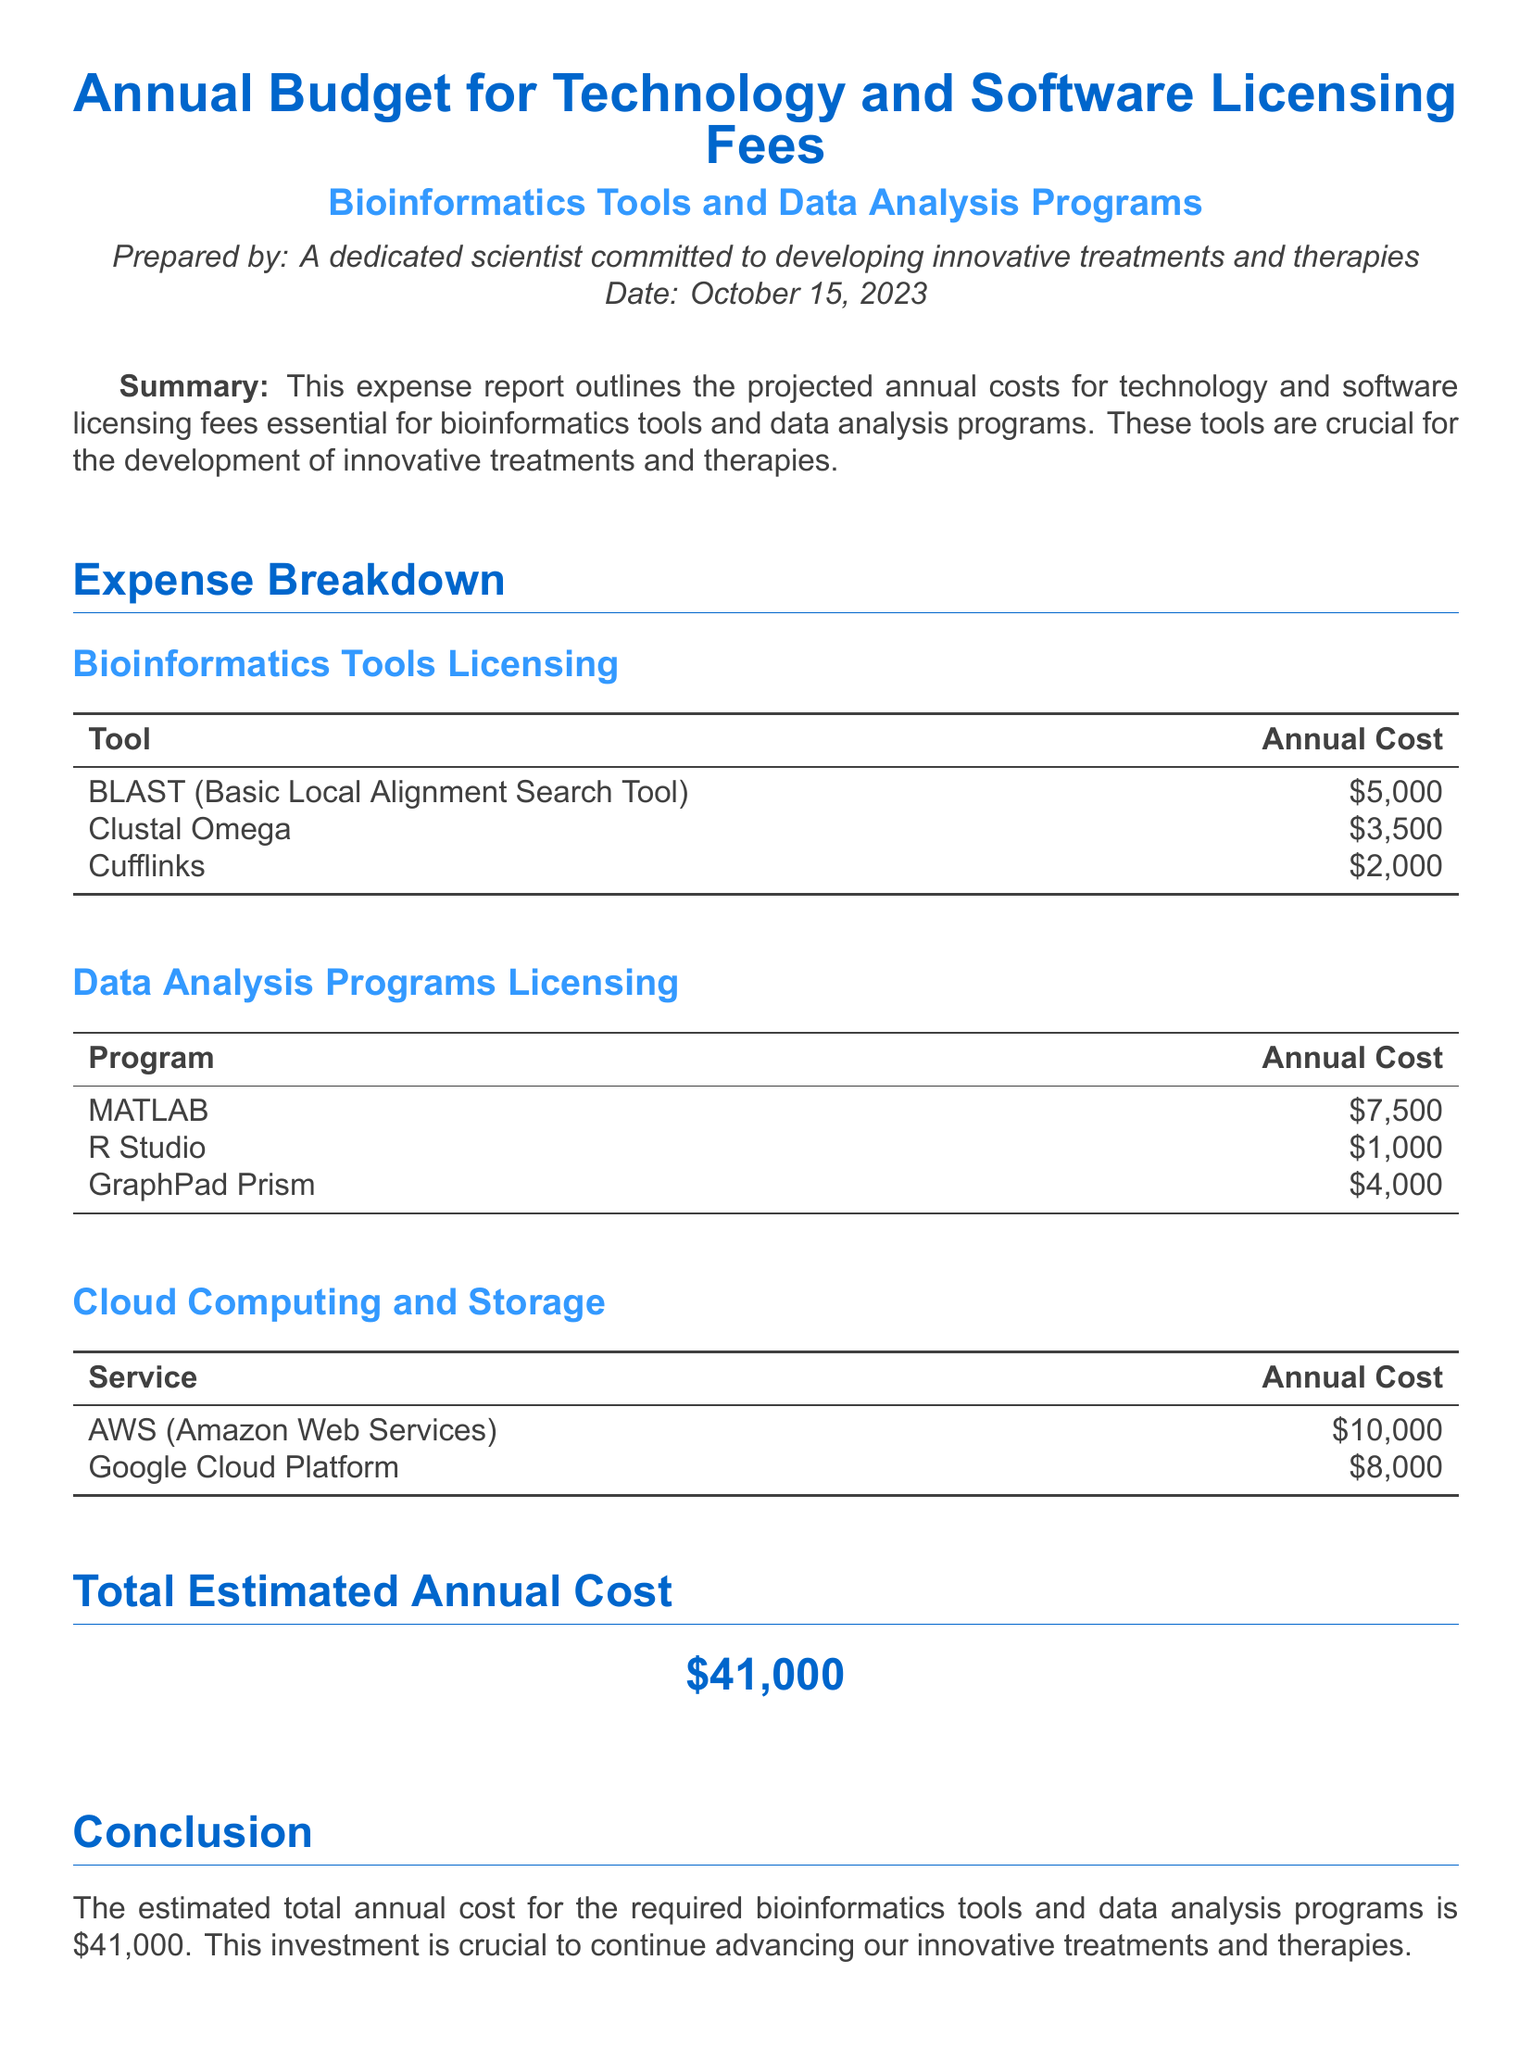what is the total estimated annual cost? The total estimated annual cost is presented in the document as the overall investment for the required tools and programs, which amounts to $41,000.
Answer: $41,000 how much does MATLAB cost annually? The document specifies the annual cost for MATLAB when listing data analysis programs licensing, which is $7,500.
Answer: $7,500 which service has the highest annual cost in cloud computing? The document provides a breakdown of cloud computing costs, identifying AWS as the service with the highest annual cost of $10,000.
Answer: AWS what are the total expenses for Bioinformatics Tools Licensing? To determine the total for Bioinformatics Tools Licensing, we sum the individual costs listed, which are $5,000, $3,500, and $2,000, totaling $10,500.
Answer: $10,500 who prepared the report? The report states that it was prepared by a dedicated scientist focused on innovative treatments and therapies, thus identifying the preparer.
Answer: A dedicated scientist what is the purpose of this document? The document outlines the projected annual costs for licensing fees that are essential for bioinformatics tools and data analysis programs, indicating its primary aim.
Answer: Expense report how many data analysis programs are listed in the report? The document lists three data analysis programs under licensing costs, which provides a specific count.
Answer: 3 what color is used for headings in the document? The document describes that headings are in a specific color indicated as heading color, which is RGB color (0, 102, 204).
Answer: RGB(0, 102, 204) which program is the least expensive in Data Analysis Programs Licensing? The document indicates that R Studio has the lowest annual cost among the listed data analysis programs at $1,000.
Answer: $1,000 what are the total expenses for Cloud Computing and Storage? The total for Cloud Computing and Storage is calculated by summing the costs of AWS and Google Cloud Platform, totaling $18,000.
Answer: $18,000 